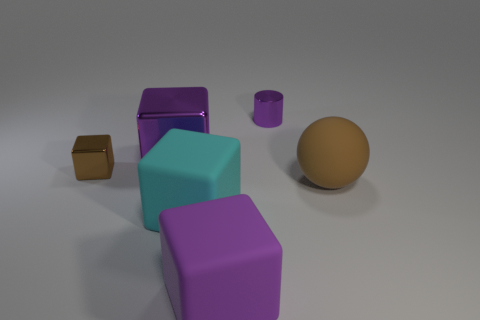Is the color of the metallic cylinder the same as the big metal object?
Provide a succinct answer. Yes. There is a rubber object that is in front of the cyan object; is its size the same as the brown object behind the sphere?
Provide a succinct answer. No. Is the brown metal thing the same shape as the purple rubber thing?
Your response must be concise. Yes. How big is the cyan rubber thing?
Provide a short and direct response. Large. Do the purple metallic cube and the brown metal thing have the same size?
Your answer should be compact. No. The big object that is both behind the cyan matte block and right of the big cyan matte thing is what color?
Your answer should be very brief. Brown. How many blocks have the same material as the big brown sphere?
Keep it short and to the point. 2. How many big matte balls are there?
Your answer should be very brief. 1. There is a brown ball; is it the same size as the purple thing in front of the brown matte ball?
Provide a short and direct response. Yes. What material is the big block behind the large thing that is right of the big purple matte block made of?
Your answer should be very brief. Metal. 